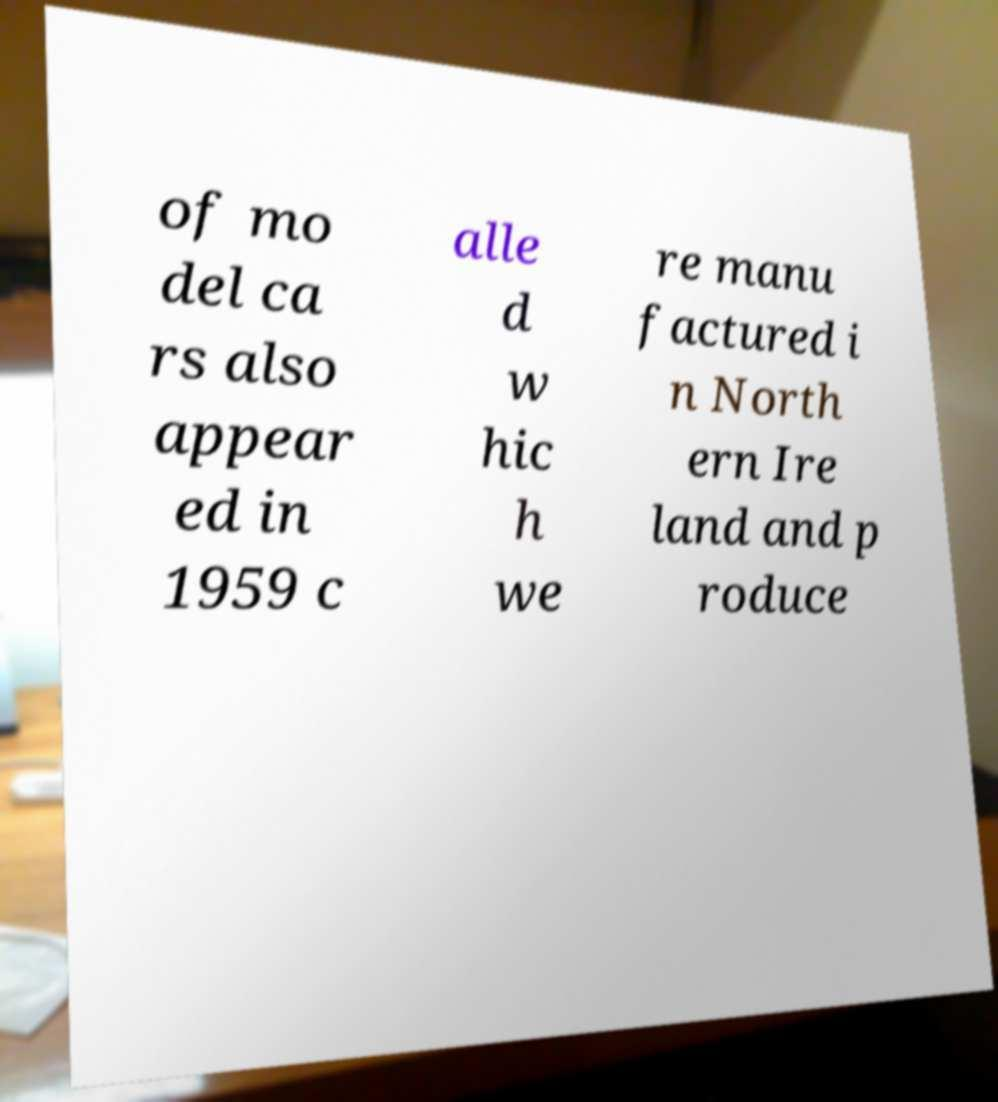There's text embedded in this image that I need extracted. Can you transcribe it verbatim? of mo del ca rs also appear ed in 1959 c alle d w hic h we re manu factured i n North ern Ire land and p roduce 